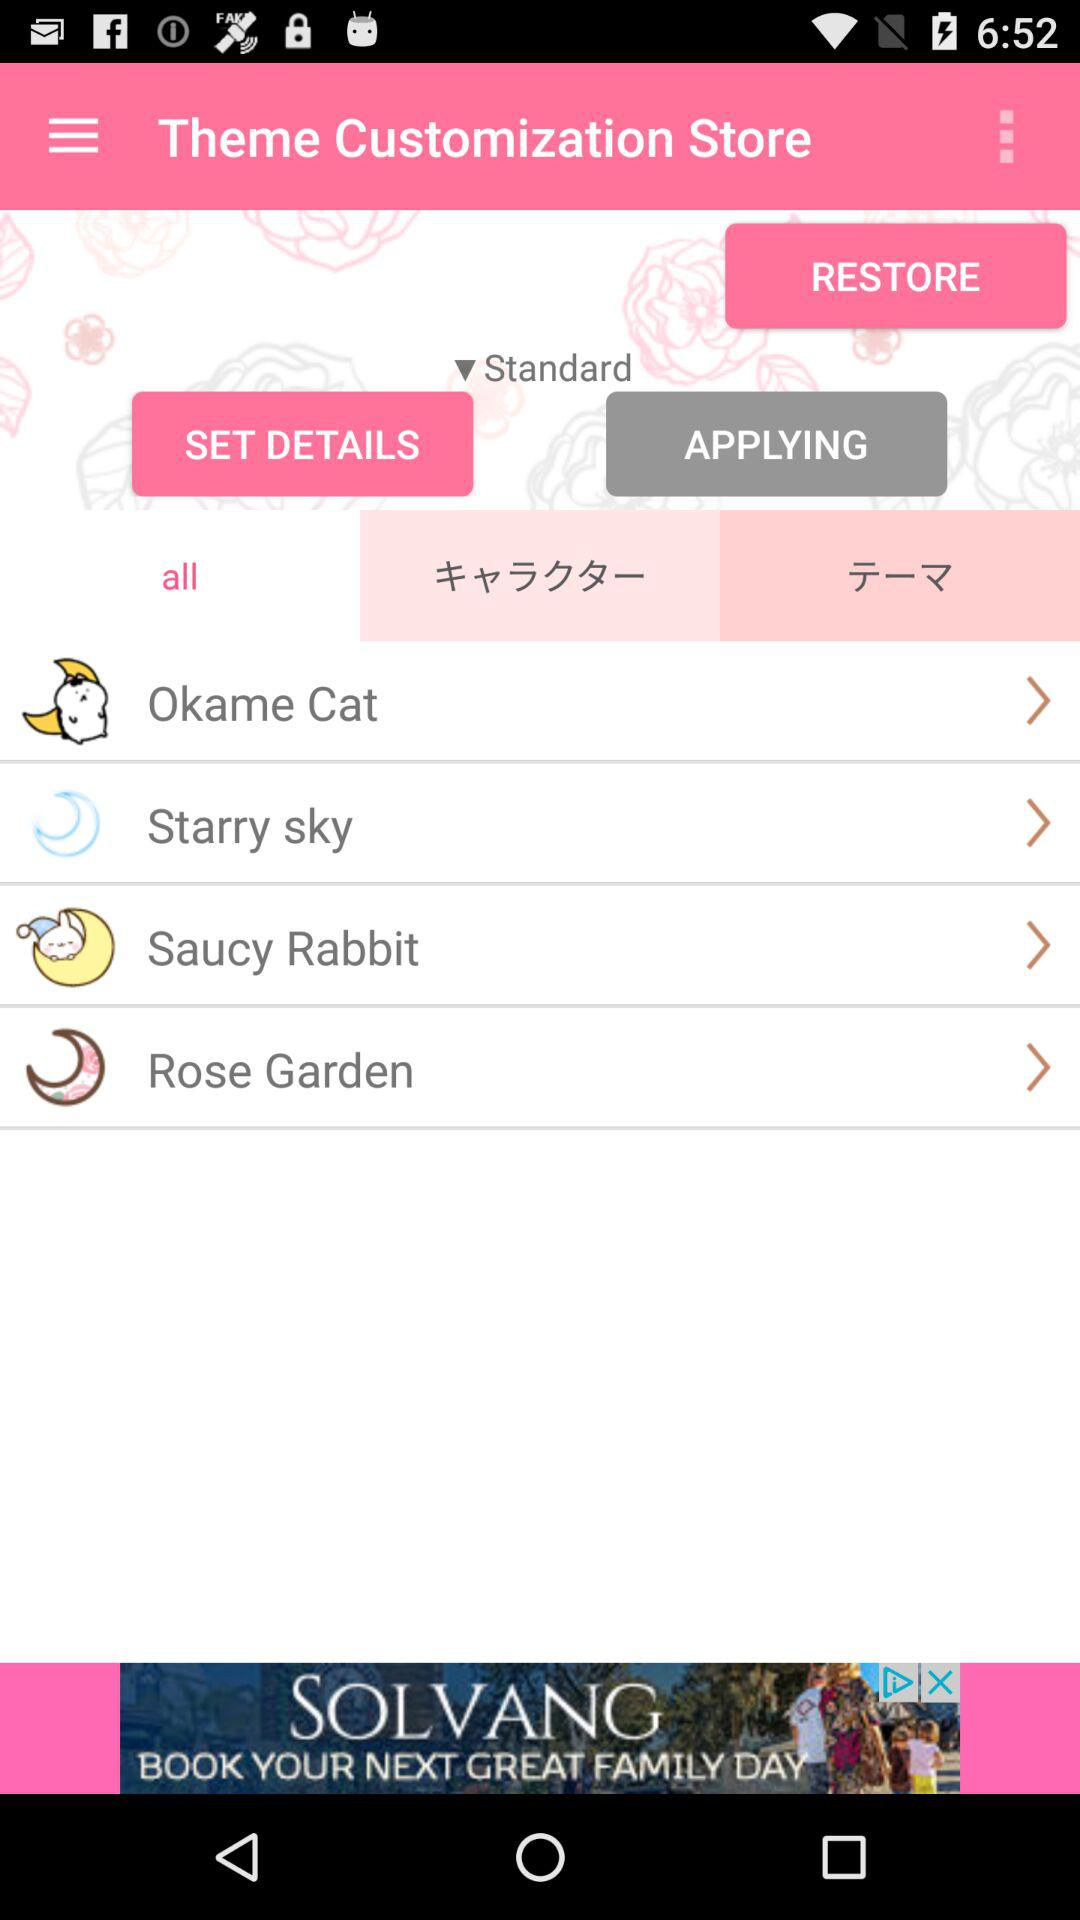Which type of theme was selected under the "Theme Customization Store"? The selected theme type was "Standard". 